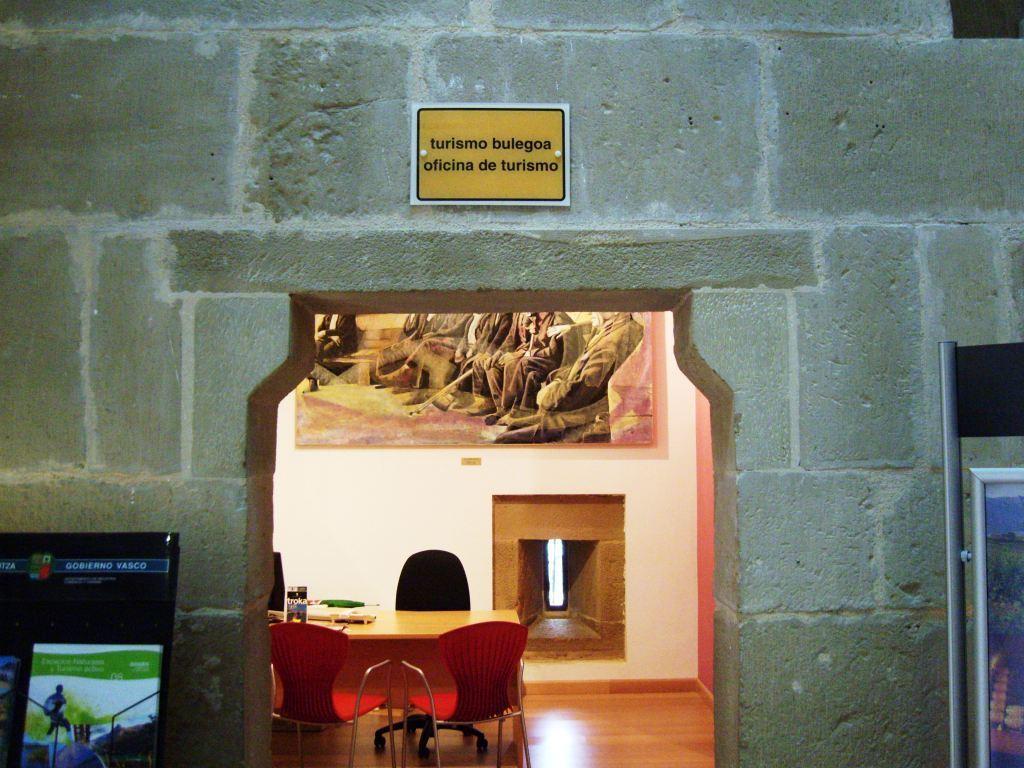Can you describe this image briefly? In this image in the center there is a wall and on the wall there is a board with some text written on it. On the left side there is a screen. On the right side there is a stand. In the center there is a table and there are chairs and on the wall there is a frame. 